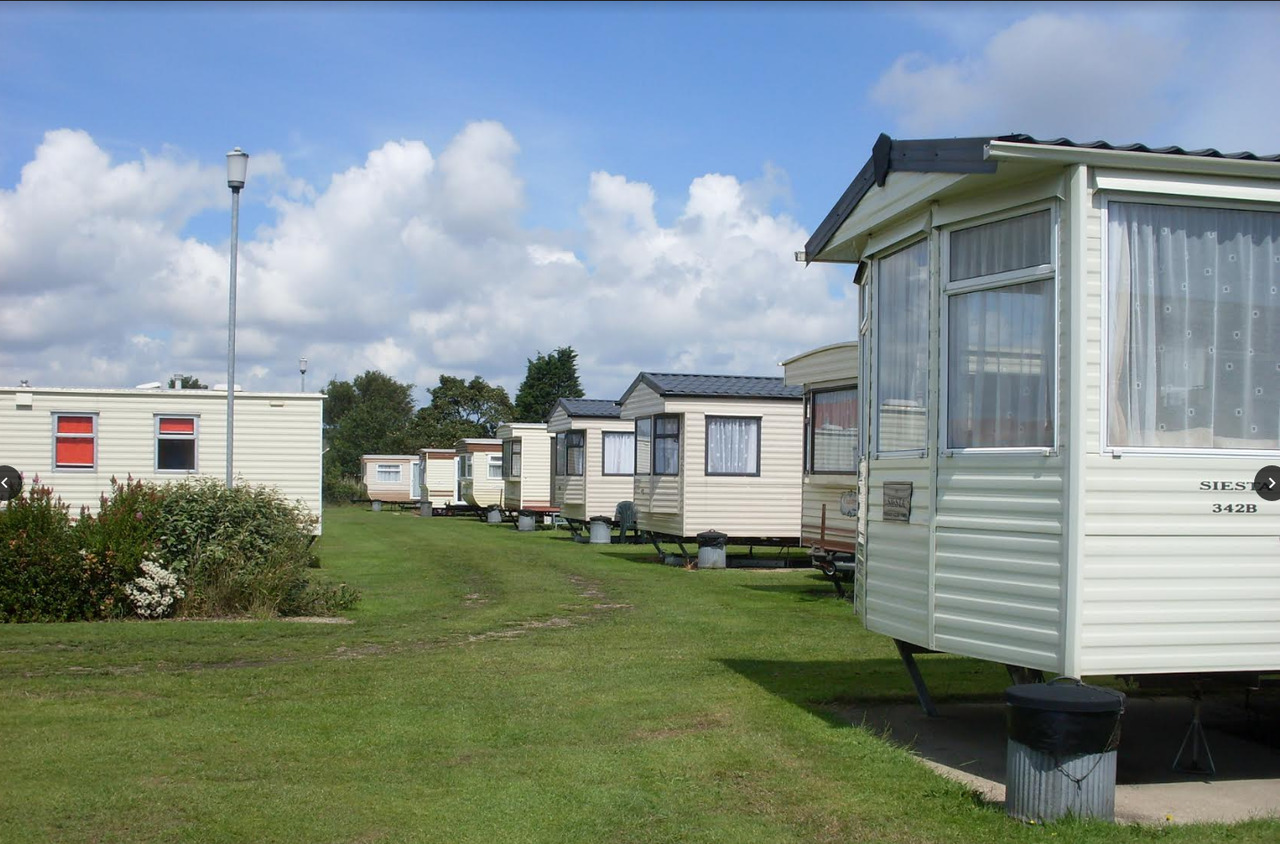If this caravan park was a scene in a novel, how would you describe the setting to evoke nostalgia? The caravans stood in neat rows under the vast expanse of the azure sky, their white facades gleaming in the gentle sunlight. The soft rustling of leaves and distant laughter painted a serene and comforting background, a slice of happiness from a bygone era. Children skipped along the well-trodden paths, their joyful cries mingling with the hum of summer insects. Families gathered around picnic tables, exchanging stories over hearty meals, while the scent of freshly cut grass filled the air. It was a place where time seemed to slow down, allowing everyone to savor the simple pleasures of life, creating memories that would linger long after the caravans had moved on. 